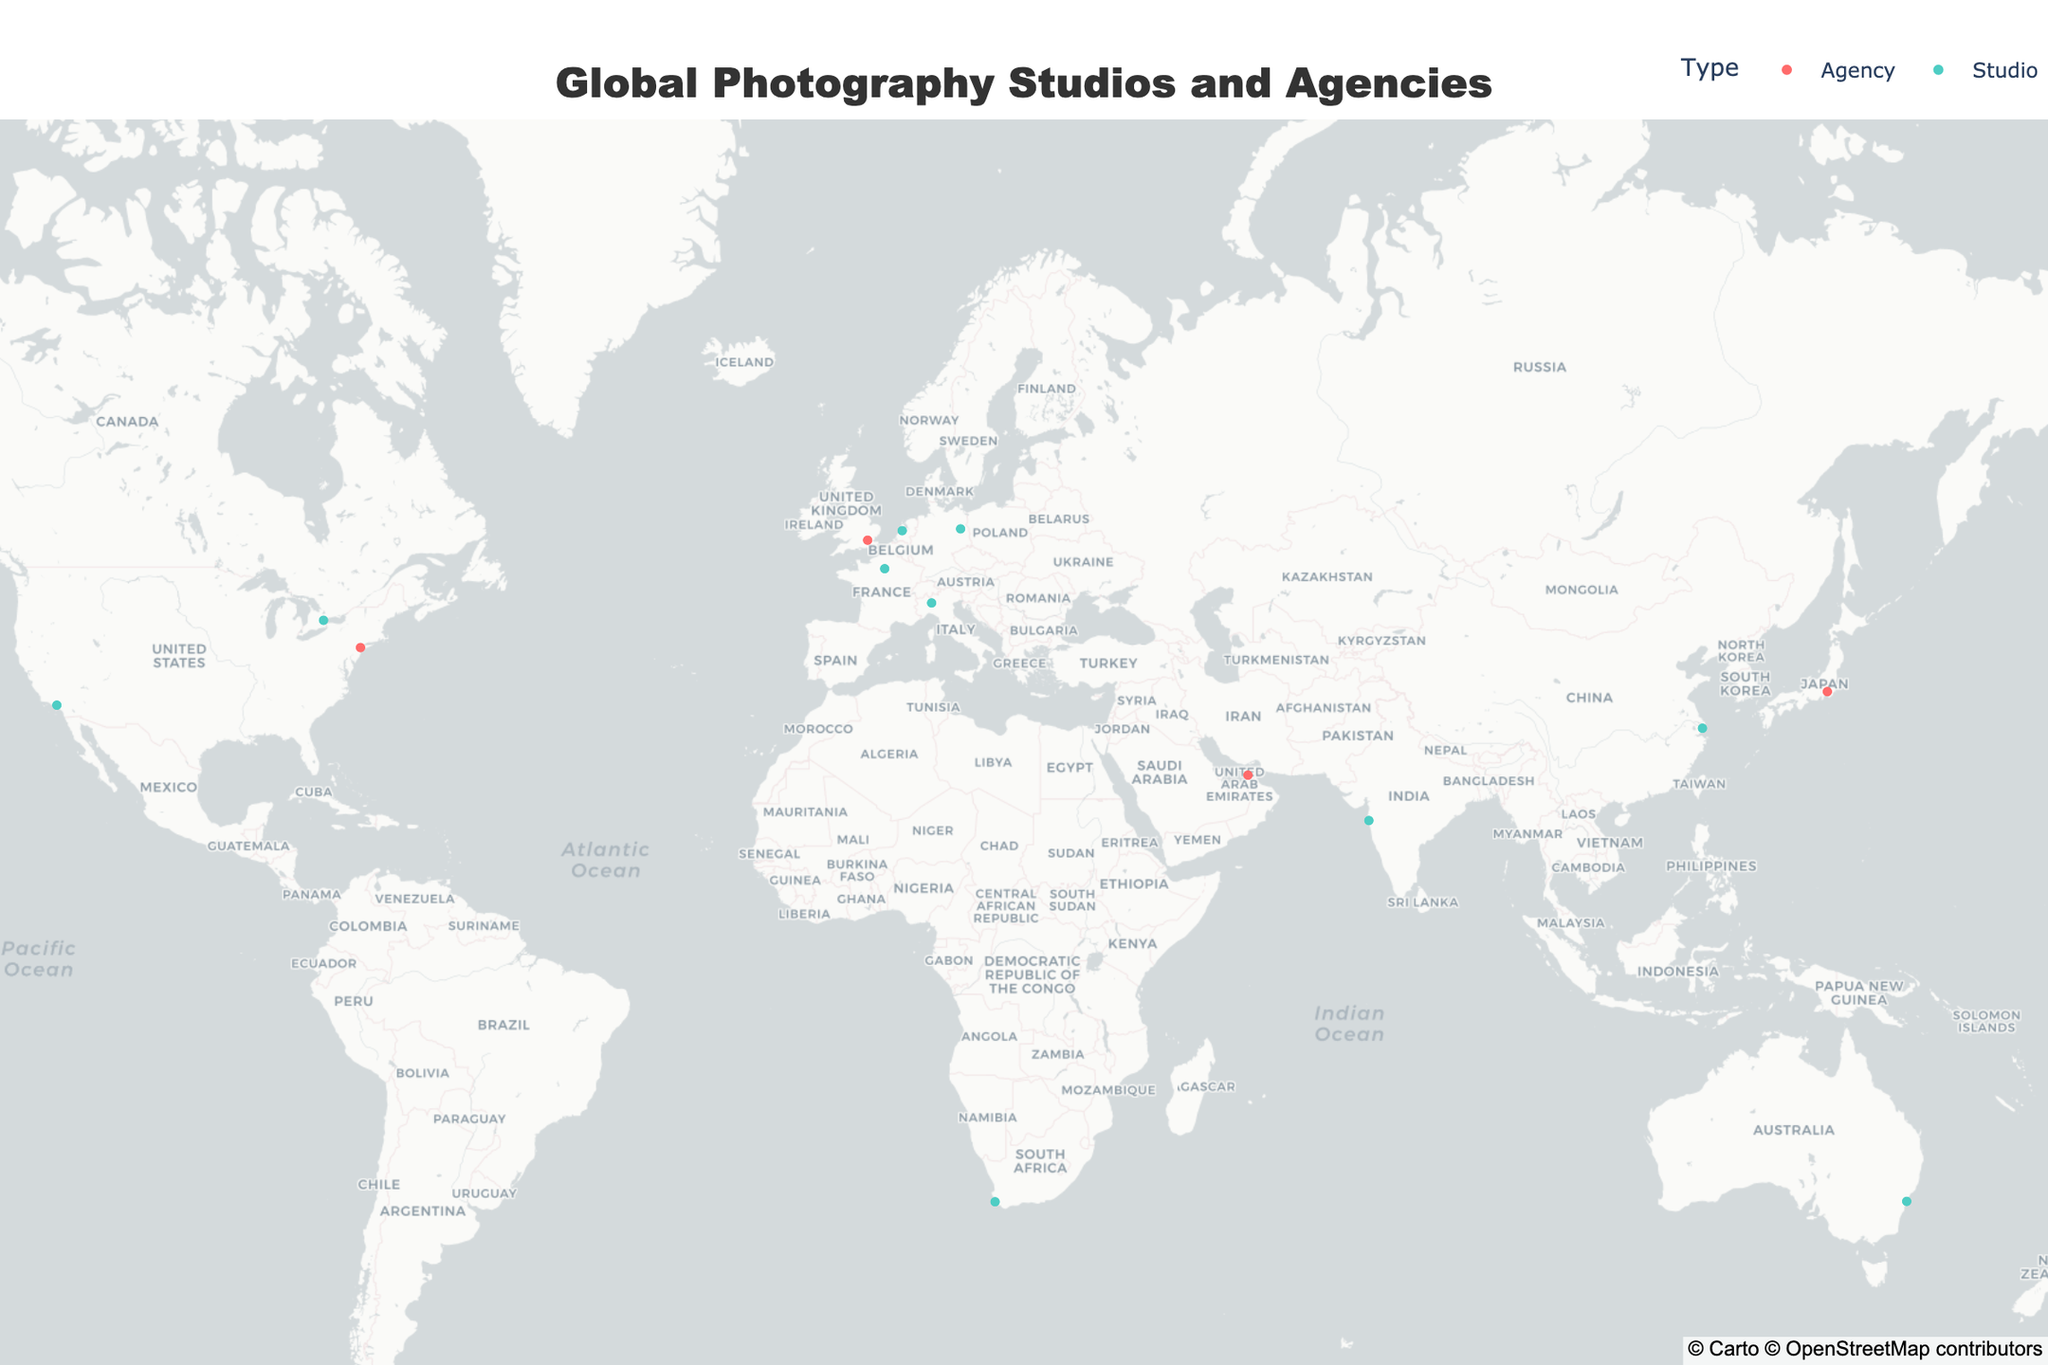What's the title of the figure? The title of the figure is displayed prominently at the top of the map, which is typical in most plotted maps to describe the overall subject.
Answer: Global Photography Studios and Agencies How many photography locations are depicted on the map? By counting the number of markers (both studio and agency) shown on the map, we can determine the total number of photography locations.
Answer: 14 What color is used to represent photography agencies? The legend at the top right indicates different types, and the color red is used for agencies.
Answer: Red Which photography studio is located in Paris? By looking at the location in Paris and examining the hover text or label next to the marker, we see that it is Studio Harcourt.
Answer: Studio Harcourt How many studios are there in total? Count all markers that are colored in teal (representing studios) according to the legend.
Answer: 10 Is there any photography studio in Africa? Checking the map for any teal-colored markers located on the African continent, we find one in Cape Town, South Africa.
Answer: Yes Which type has more locations globally, studios or agencies? Count the number of markers for each type: there are 10 studios (teal markers) and only 4 agencies (red markers).
Answer: Studios Which city has both a high concentration of photography institutions and is relatively far from Europe? By looking at the map, noting the two institutions in USA, especially New York which has Getty Images and is notably far from Europe.
Answer: New York Which is the southernmost photography studio or agency on the map? Identify the marker that is closest to the bottom of the map, representing the southernmost point, which is The Foxtel Studios in Sydney, Australia.
Answer: The Foxtel Studios, Sydney How does the distribution of studios compare internationally? By examining the global spread: Most photography studios are concentrated in major cities worldwide such as Los Angeles, Berlin, Sydney, etc., with a diverse international presence.
Answer: Studios are widely spread across major global cities 